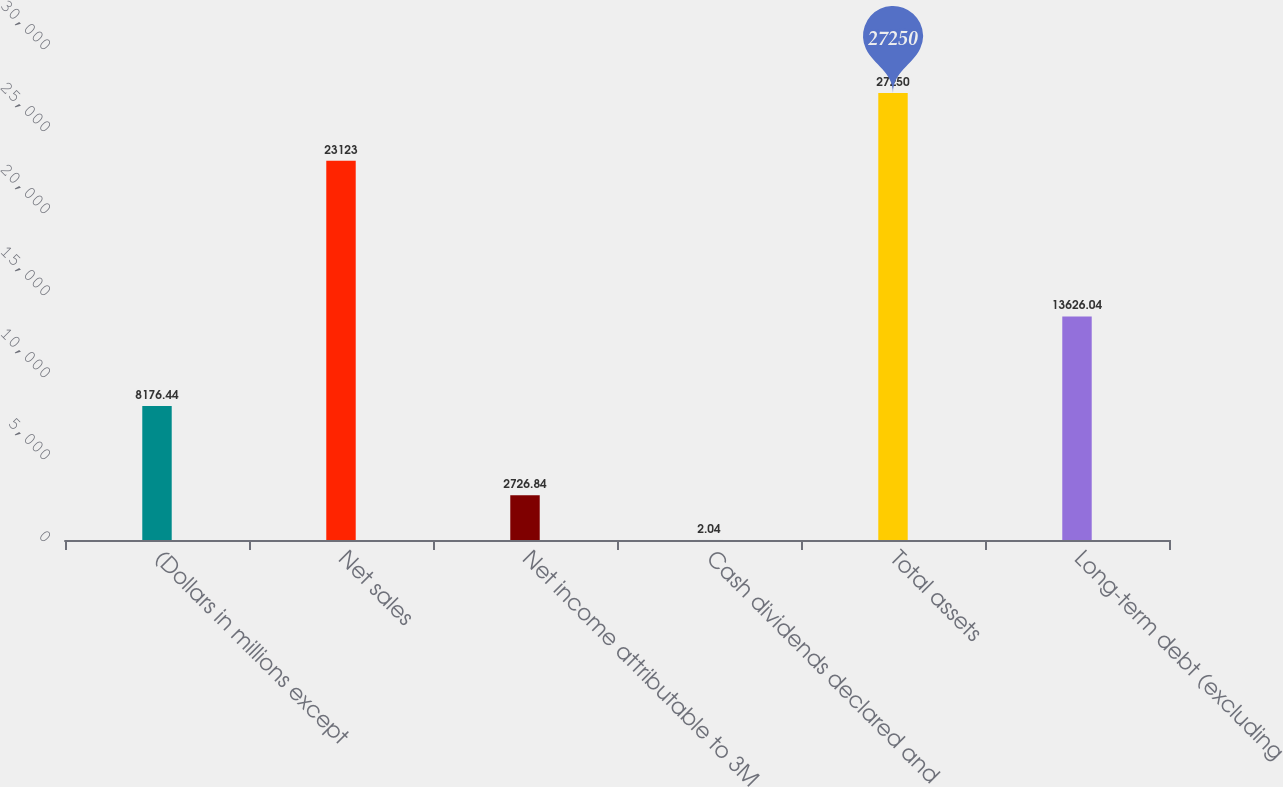Convert chart. <chart><loc_0><loc_0><loc_500><loc_500><bar_chart><fcel>(Dollars in millions except<fcel>Net sales<fcel>Net income attributable to 3M<fcel>Cash dividends declared and<fcel>Total assets<fcel>Long-term debt (excluding<nl><fcel>8176.44<fcel>23123<fcel>2726.84<fcel>2.04<fcel>27250<fcel>13626<nl></chart> 